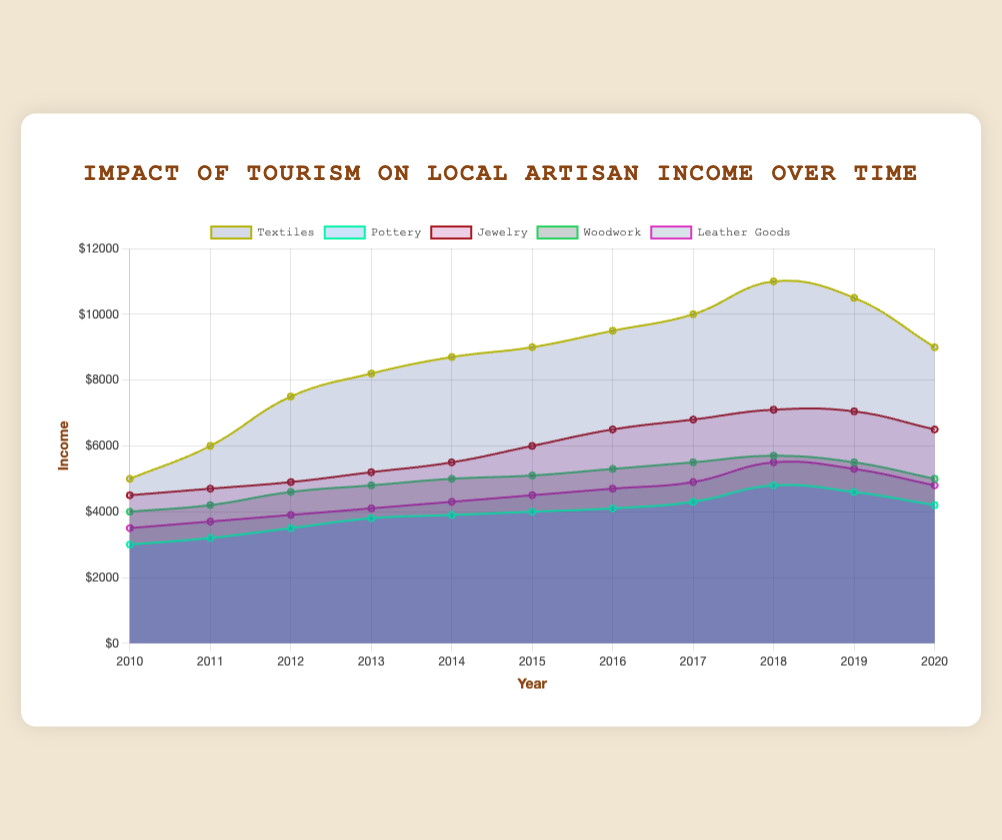What is the title of the chart? The title of the chart is displayed prominently at the top of the figure. The title is "Impact of Tourism on Local Artisan Income Over Time".
Answer: "Impact of Tourism on Local Artisan Income Over Time" Which craft type had the highest income in 2018? To determine this, look at the respective income values of each craft type for 2018 and identify the highest one. Textiles had an income of 11,000 in 2018, which is the highest among all craft types.
Answer: Textiles What is the difference in income between Textiles and Woodwork in 2020? Subtract the 2020 income of Woodwork from the 2020 income of Textiles. The income for Textiles in 2020 is 9,000, and for Woodwork, it is 5,000. Therefore, 9,000 - 5,000 = 4,000.
Answer: 4,000 Which craft had the least growth in income from 2010 to 2020? Calculate the difference in income from 2010 to 2020 for all crafts. Pottery grew from 3,000 to 4,200, which is a growth of 1,200, the smallest among all crafts.
Answer: Pottery Is there a year when all craft types showed an increase in income compared to the previous year? If so, which year? Check each year to see if the income for each craft increased compared to the previous year. In 2016, all craft types show an increase in income compared to 2015.
Answer: 2016 Which craft experienced the highest decline in income between any two consecutive years? Examine the data for each craft to find the maximum drop in income between consecutive years. Textiles had a significant drop from 2019 to 2020, decreasing from 10,500 to 9,000, which is a decline of 1,500.
Answer: Textiles (2019 to 2020) What's the total income for Leather Goods from 2010 to 2020? Sum the income values of Leather Goods for each year from 2010 to 2020. The total is 3,500 + 3,700 + 3,900 + 4,100 + 4,300 + 4,500 + 4,700 + 4,900 + 5,500 + 5,300 + 4,800 = 48,200.
Answer: 48,200 How did the income for Jewelry change from 2015 to 2017? Observe the income values for Jewelry in 2015, 2016, and 2017. The income increased from 6,000 in 2015 to 6,500 in 2016, and then to 6,800 in 2017. The total change is an increase of 800.
Answer: Increased by 800 Which craft types had an income of over $10,000 in any year? Check the income values of each craft type for all years to see which crossed the $10,000 mark. Only Textiles had an income over $10,000 in 2018 and 2019.
Answer: Textiles In what year did Woodwork income reach a peak? Review the income values for Woodwork across all years to find the maximum value. Woodwork reached its peak income of 5,700 in 2018.
Answer: 2018 